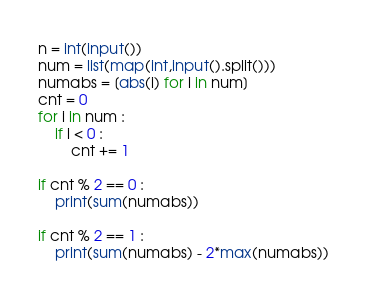<code> <loc_0><loc_0><loc_500><loc_500><_Python_>n = int(input())
num = list(map(int,input().split()))
numabs = [abs(i) for i in num]
cnt = 0           
for i in num :
    if i < 0 :
        cnt += 1

if cnt % 2 == 0 :
    print(sum(numabs))

if cnt % 2 == 1 :
    print(sum(numabs) - 2*max(numabs))</code> 